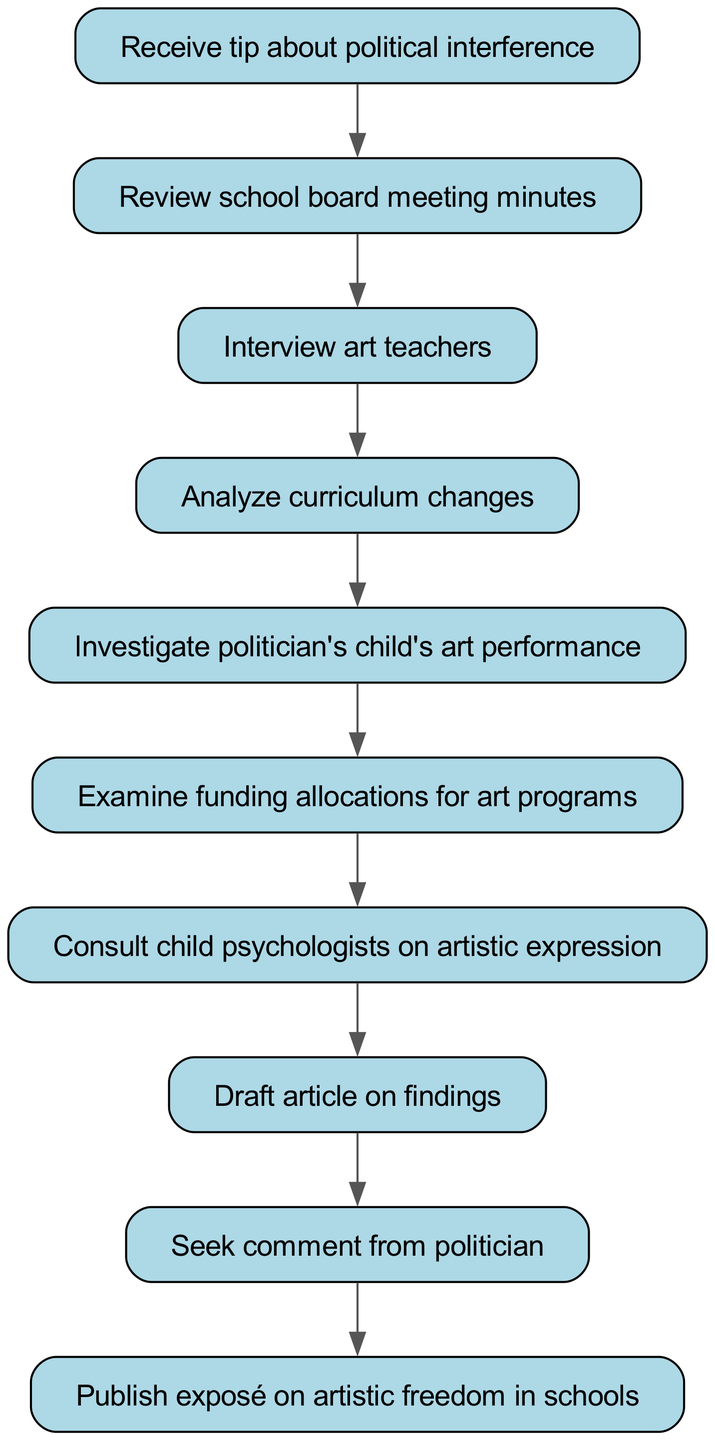what is the starting point of the pathway? The pathway begins with receiving a tip about political interference, which is the first node in the diagram.
Answer: Receive tip about political interference how many nodes are there in the diagram? The diagram consists of 10 nodes, representing various steps in the investigation process.
Answer: 10 what is the relationship between investigating the politician's child's art performance and analyzing curriculum changes? Analyzing curriculum changes is a prerequisite step before investigating the politician's child's art performance, as indicated by the directed edge connecting the two nodes.
Answer: Analyzing curriculum changes precedes investigating the politician's child's art performance what is the final action in the pathway? The final action in the pathway is to publish an exposé on artistic freedom in schools, represented as the last node in the diagram.
Answer: Publish exposé on artistic freedom in schools what is needed before consulting child psychologists on artistic expression? Before consulting child psychologists, it is necessary to examine funding allocations for art programs, as indicated by the direct edge leading to this action.
Answer: Examine funding allocations for art programs how many distinct actions are taken after reviewing school board meeting minutes? After reviewing school board meeting minutes, there are three distinct actions that follow: interviewing art teachers, analyzing curriculum changes, and seeking comment from the politician.
Answer: Three what step comes immediately after interviewing art teachers? After interviewing art teachers, the next step is to analyze curriculum changes, indicated by the direct edge leading from the interview node to the analysis node.
Answer: Analyze curriculum changes what step comes before drafting an article on findings? Before drafting an article on findings, one must consult child psychologists on artistic expression, as per the flow of the diagram.
Answer: Consult child psychologists on artistic expression which node involves seeking a comment from a politician? The node that involves seeking a comment from a politician occurs after drafting the article on findings.
Answer: Seek comment from politician 